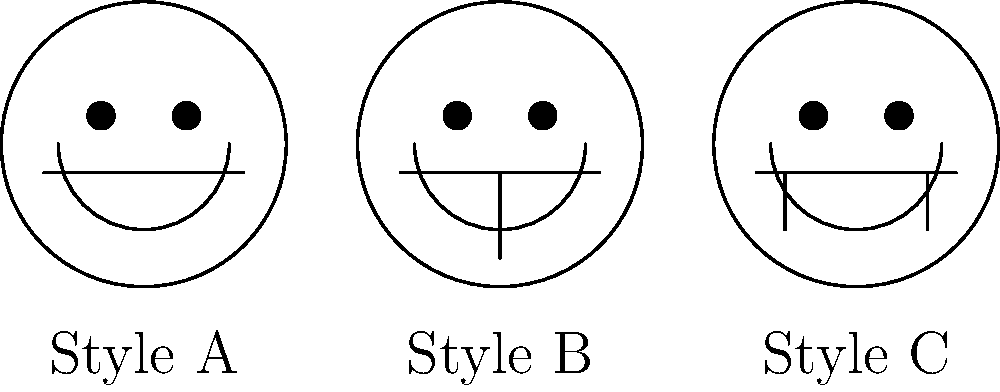As a barbershop owner with experience in various beard styles, which machine learning approach would be most suitable for classifying beard styles based on the facial hair patterns shown in the image? To classify beard styles based on facial hair patterns in images, we need to consider the following steps:

1. Image preprocessing: Normalize and standardize the input images.
2. Feature extraction: Identify key features that distinguish different beard styles.
3. Model selection: Choose an appropriate machine learning algorithm.
4. Training: Use a labeled dataset of beard styles to train the model.
5. Evaluation: Test the model's performance on unseen data.

For this specific problem:

1. The images show clear, distinct patterns for each beard style.
2. The key features are the presence and shape of facial hair in different regions.
3. Given the visual nature of the problem and the need to recognize patterns, a Convolutional Neural Network (CNN) would be most suitable.

CNNs are particularly effective for image classification tasks because:

a) They can automatically learn hierarchical features from raw pixel data.
b) They use convolutional layers to detect local patterns and spatial relationships.
c) They are translation-invariant, meaning they can detect features regardless of their position in the image.
d) They have shown excellent performance in various image classification tasks, including facial feature recognition.

A CNN can learn to identify the presence of mustaches, chin straps, and full beards, as well as their shapes and combinations, which are crucial for distinguishing between the styles shown in the image.
Answer: Convolutional Neural Network (CNN) 